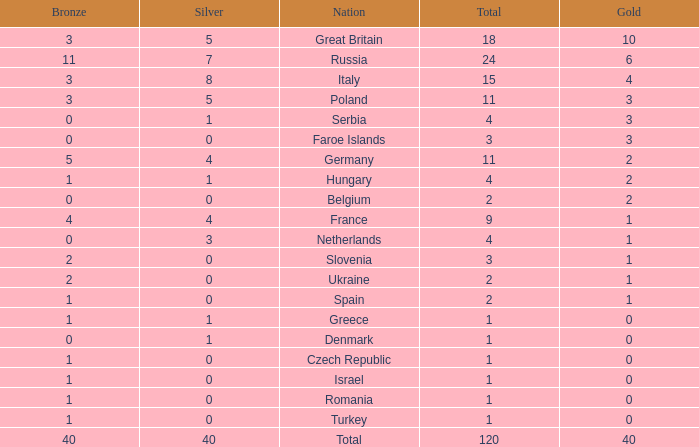What is the average Gold entry for the Netherlands that also has a Bronze entry that is greater than 0? None. 